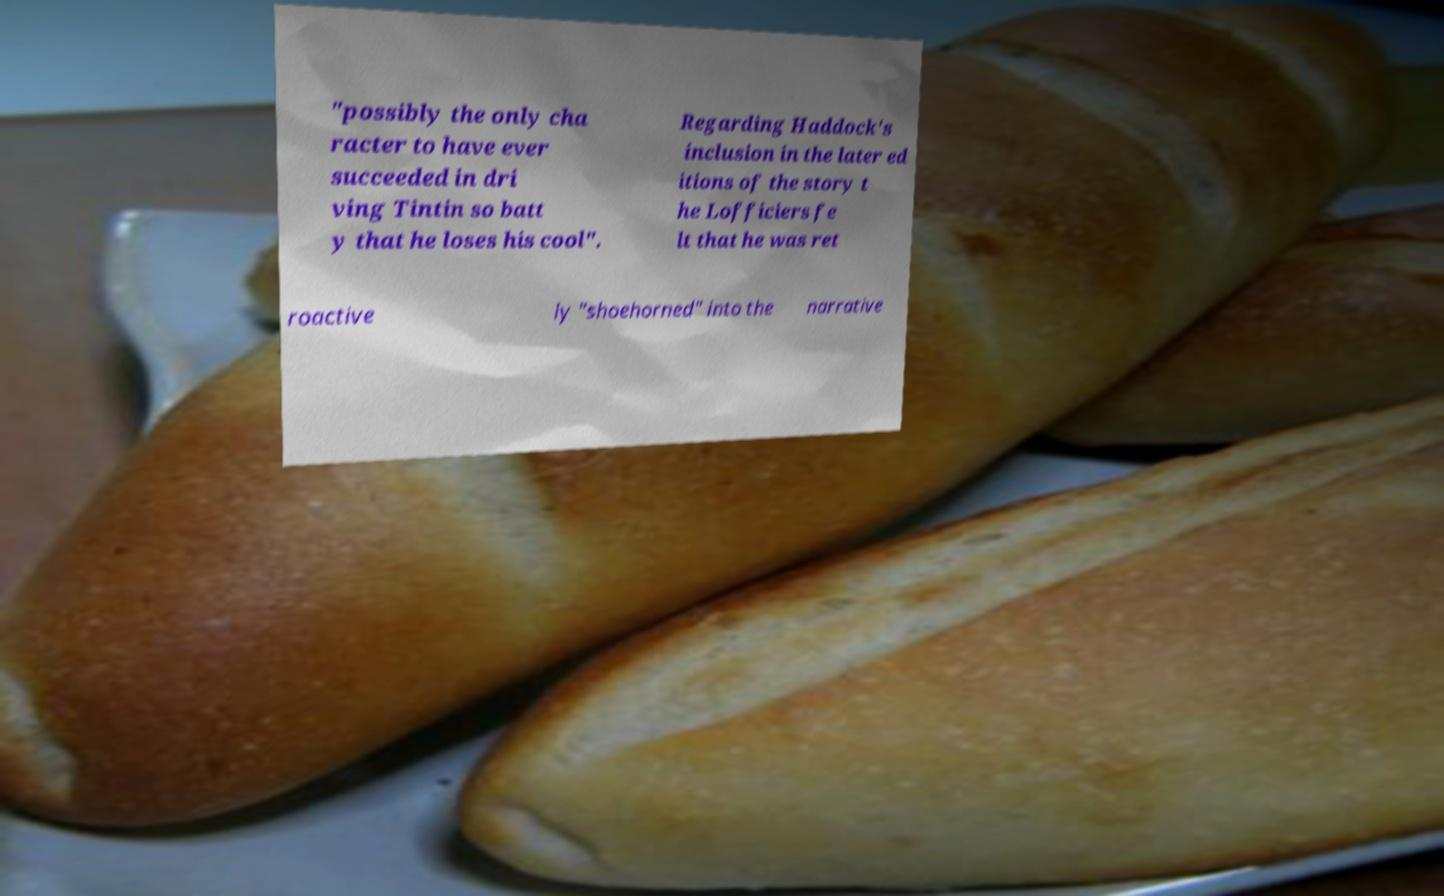Could you extract and type out the text from this image? "possibly the only cha racter to have ever succeeded in dri ving Tintin so batt y that he loses his cool". Regarding Haddock's inclusion in the later ed itions of the story t he Lofficiers fe lt that he was ret roactive ly "shoehorned" into the narrative 